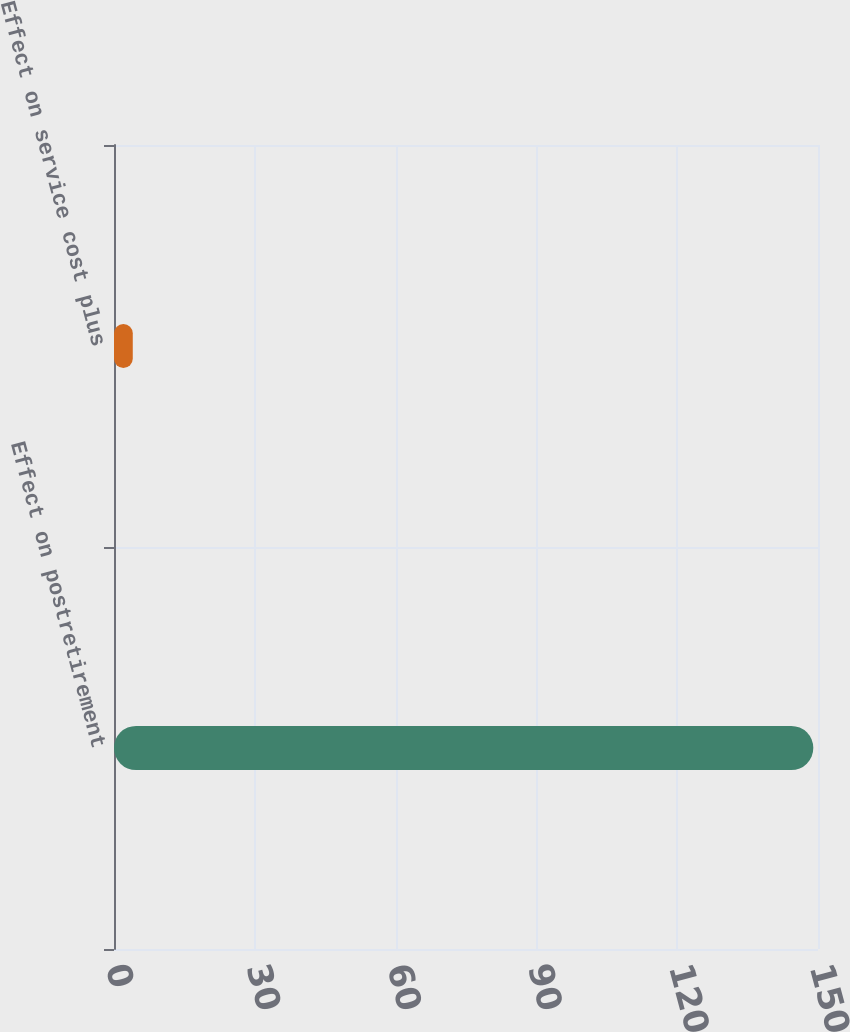Convert chart to OTSL. <chart><loc_0><loc_0><loc_500><loc_500><bar_chart><fcel>Effect on postretirement<fcel>Effect on service cost plus<nl><fcel>149<fcel>4<nl></chart> 